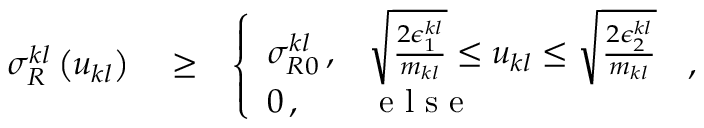<formula> <loc_0><loc_0><loc_500><loc_500>\begin{array} { r l r } { \sigma _ { R } ^ { k l } \left ( u _ { k l } \right ) } & \geq } & { \left \{ \begin{array} { l l } { \sigma _ { R 0 } ^ { k l } \, , } & { \sqrt { \frac { 2 \epsilon _ { 1 } ^ { k l } } { m _ { k l } } } \leq u _ { k l } \leq \sqrt { \frac { 2 \epsilon _ { 2 } ^ { k l } } { m _ { k l } } } } \\ { 0 \, , } & { e l s e } \end{array} \, , } \end{array}</formula> 